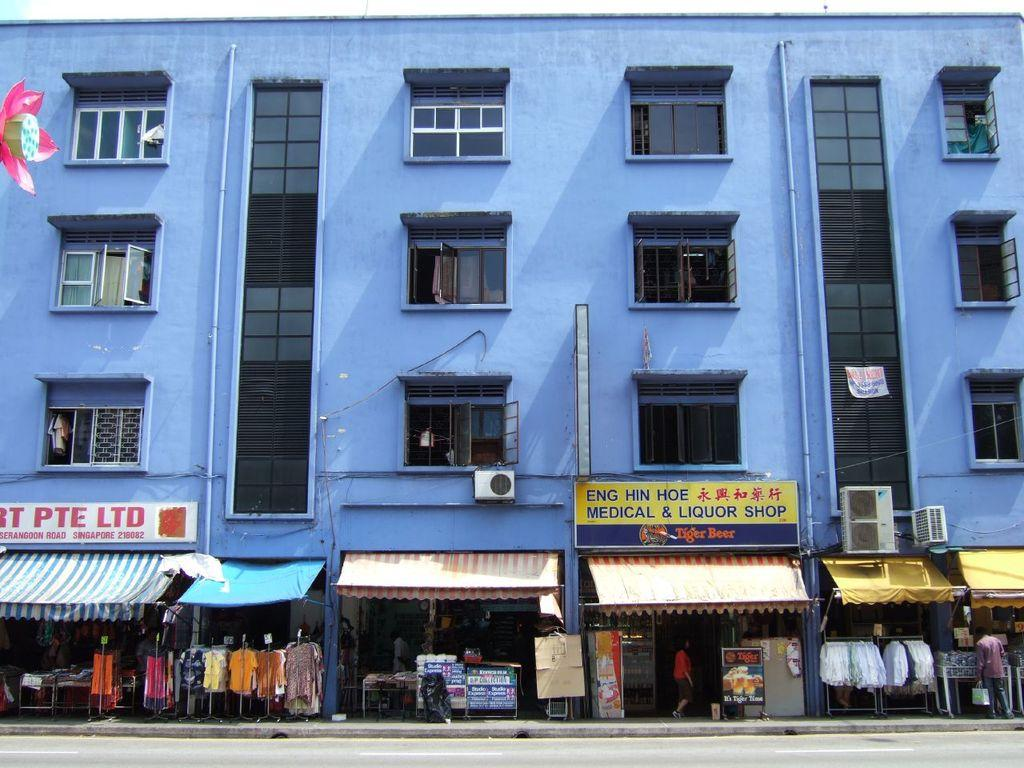What type of establishments can be seen in the image? There are stores in the image. What objects are present in the image that might be used for displaying information or advertisements? There are boards in the image. What type of large appliances can be seen in the image? There are air conditioner boxes in the image. What is the color of the building in the image? The building in the image is blue. What type of windows does the building have? The building has many glass windows. Can you see any wounds on the building in the image? There are no wounds visible on the building in the image. Is there a partner store next to the blue building in the image? The image does not provide information about any partner stores, so it cannot be determined from the image. 